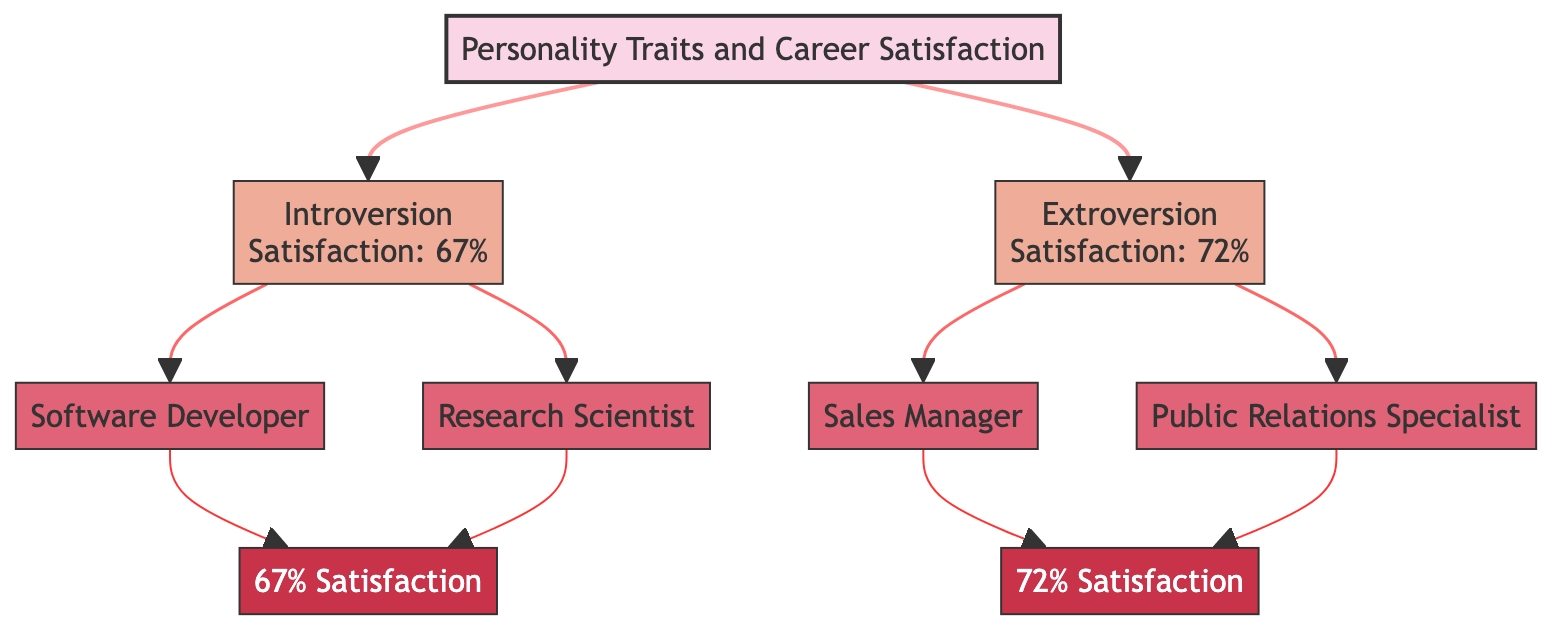What are the two main personality traits shown in the diagram? The diagram highlights two primary personality traits, which are 'Introversion' and 'Extroversion.' These are the only traits listed as branches from the root node.
Answer: Introversion, Extroversion How many career paths are linked to Introversion? From the 'Introversion' node, there are two career paths connected: 'Software Developer' and 'Research Scientist.' Thus, counting these gives us the total.
Answer: 2 What is the satisfaction level for a Software Developer? Looking at the 'Software Developer' node, the satisfaction level is explicitly mentioned as '67% Satisfaction,' which directly answers the query.
Answer: 67% Satisfaction Which career path corresponds to Extroversion with the highest satisfaction level? Among the careers stemming from 'Extroversion,' both 'Sales Manager' and 'Public Relations Specialist' exist. The satisfaction level for 'Sales Manager' (72%) is higher than that for 'Public Relations Specialist,' which would have to be indirectly inferred as lower based on its position.
Answer: Sales Manager How many total nodes are present in the diagram? By counting all nodes, including the root, personality trait nodes, career nodes, and satisfaction nodes. The total comes to eight nodes throughout the entire diagram.
Answer: 8 Which personality trait leads to the career path of Research Scientist? The node 'Research Scientist' can be traced back to 'Introversion,' meaning that this personality trait is what leads to that career path based on the decision tree structure.
Answer: Introversion What is the satisfaction level for Extroversion-related career paths? The satisfaction level for careers connected to 'Extroversion' is uniformly '72% Satisfaction,' as noted by the 'Sales Manager' and inferred as equal for both careers beneath that branch.
Answer: 72% Satisfaction What type of analysis does this diagram represent? This diagram utilizes a decision tree analysis to elucidate how personality traits influence career satisfaction and options. This can be identified by its branching structure tying traits to outcomes.
Answer: Decision tree analysis 